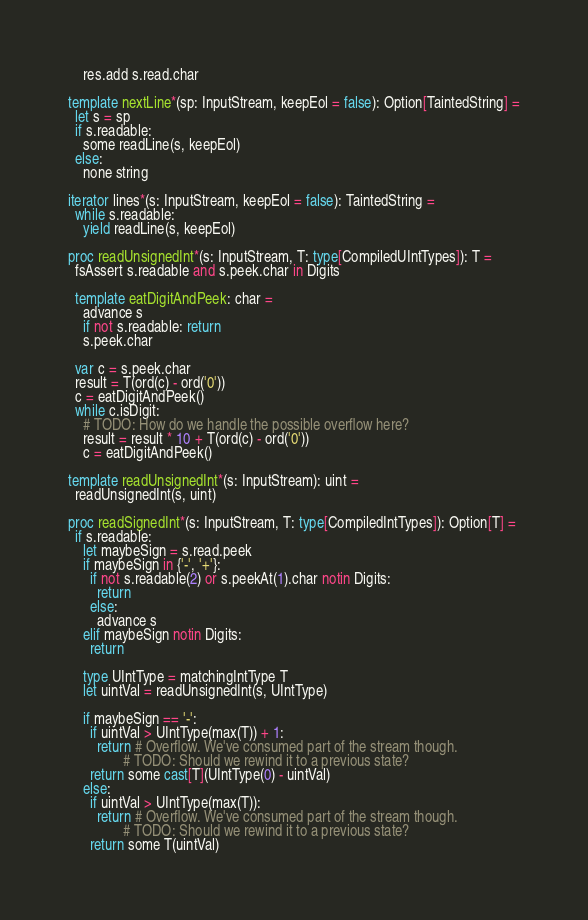Convert code to text. <code><loc_0><loc_0><loc_500><loc_500><_Nim_>    res.add s.read.char

template nextLine*(sp: InputStream, keepEol = false): Option[TaintedString] =
  let s = sp
  if s.readable:
    some readLine(s, keepEol)
  else:
    none string

iterator lines*(s: InputStream, keepEol = false): TaintedString =
  while s.readable:
    yield readLine(s, keepEol)

proc readUnsignedInt*(s: InputStream, T: type[CompiledUIntTypes]): T =
  fsAssert s.readable and s.peek.char in Digits

  template eatDigitAndPeek: char =
    advance s
    if not s.readable: return
    s.peek.char

  var c = s.peek.char
  result = T(ord(c) - ord('0'))
  c = eatDigitAndPeek()
  while c.isDigit:
    # TODO: How do we handle the possible overflow here?
    result = result * 10 + T(ord(c) - ord('0'))
    c = eatDigitAndPeek()

template readUnsignedInt*(s: InputStream): uint =
  readUnsignedInt(s, uint)

proc readSignedInt*(s: InputStream, T: type[CompiledIntTypes]): Option[T] =
  if s.readable:
    let maybeSign = s.read.peek
    if maybeSign in {'-', '+'}:
      if not s.readable(2) or s.peekAt(1).char notin Digits:
        return
      else:
        advance s
    elif maybeSign notin Digits:
      return

    type UIntType = matchingIntType T
    let uintVal = readUnsignedInt(s, UIntType)

    if maybeSign == '-':
      if uintVal > UIntType(max(T)) + 1:
        return # Overflow. We've consumed part of the stream though.
               # TODO: Should we rewind it to a previous state?
      return some cast[T](UIntType(0) - uintVal)
    else:
      if uintVal > UIntType(max(T)):
        return # Overflow. We've consumed part of the stream though.
               # TODO: Should we rewind it to a previous state?
      return some T(uintVal)

</code> 